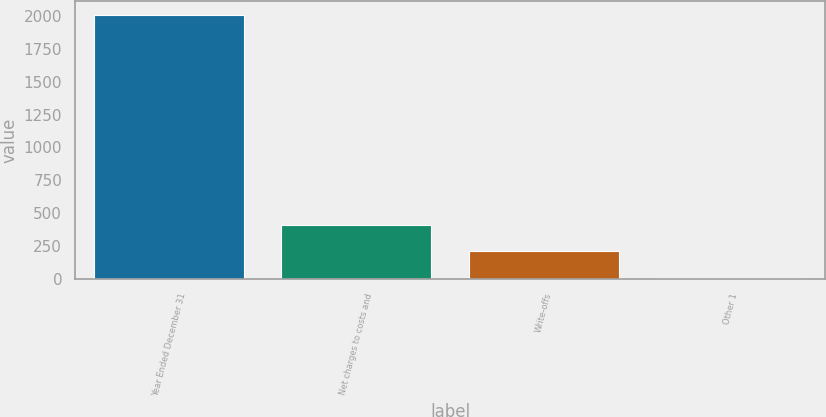Convert chart to OTSL. <chart><loc_0><loc_0><loc_500><loc_500><bar_chart><fcel>Year Ended December 31<fcel>Net charges to costs and<fcel>Write-offs<fcel>Other 1<nl><fcel>2011<fcel>409.4<fcel>209.2<fcel>9<nl></chart> 